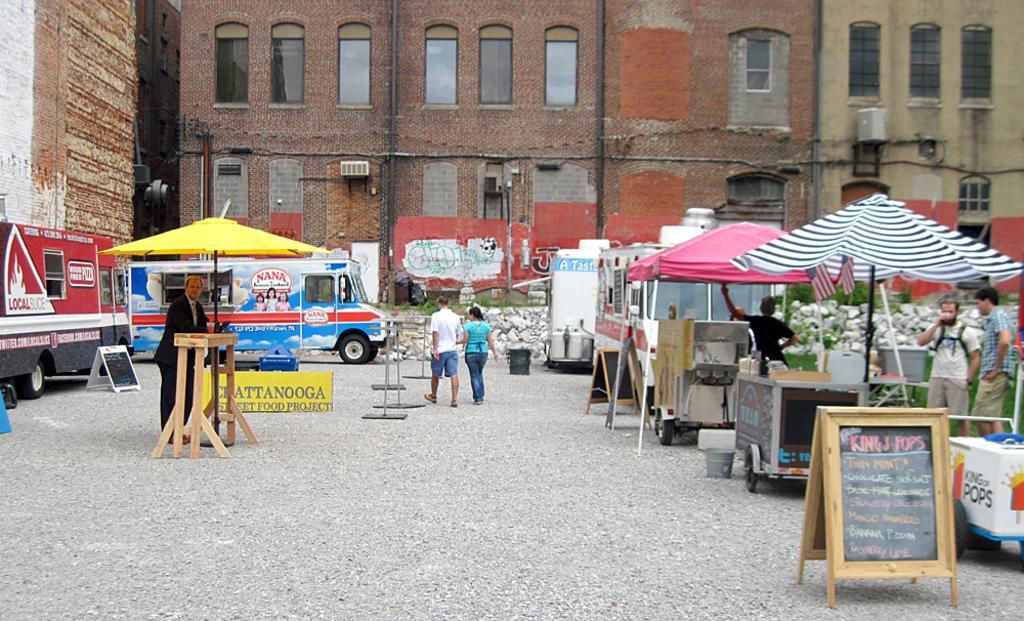In one or two sentences, can you explain what this image depicts? In the middle of the image there are some umbrellas and banners and tables and vehicles and few people are standing and walking. At the top of the image there are some buildings. 